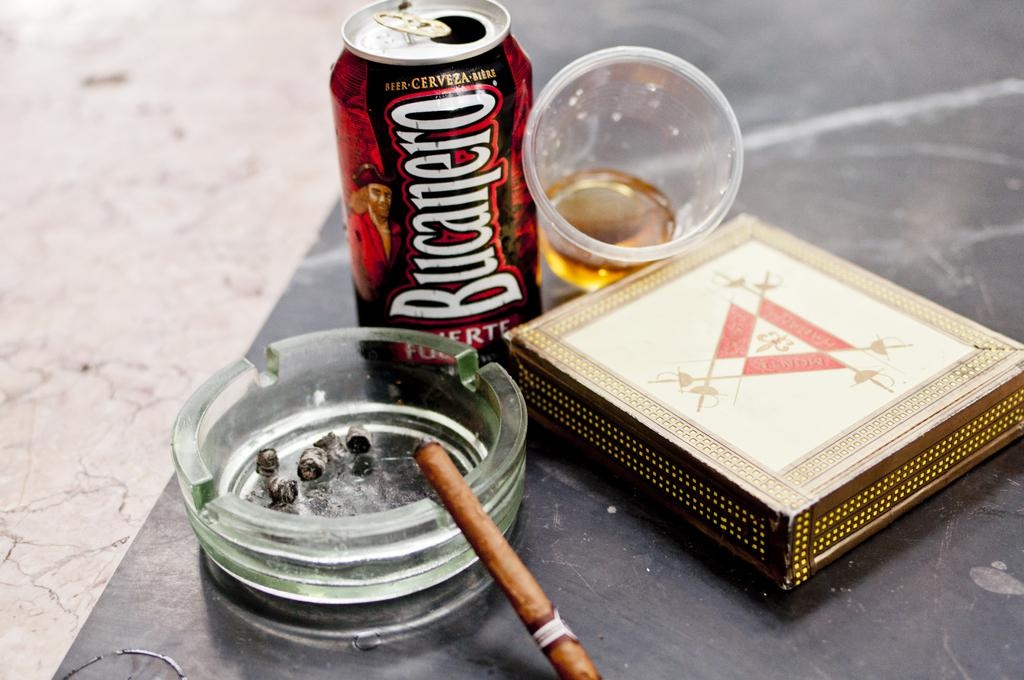Provide a one-sentence caption for the provided image. A can of BUCANERO beer is pictured near an ashtray, cup with beer in it, and a box. 